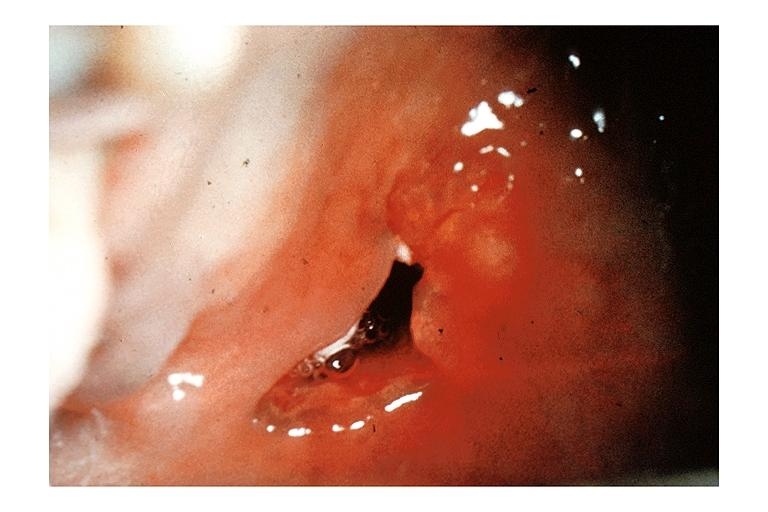s oral present?
Answer the question using a single word or phrase. Yes 